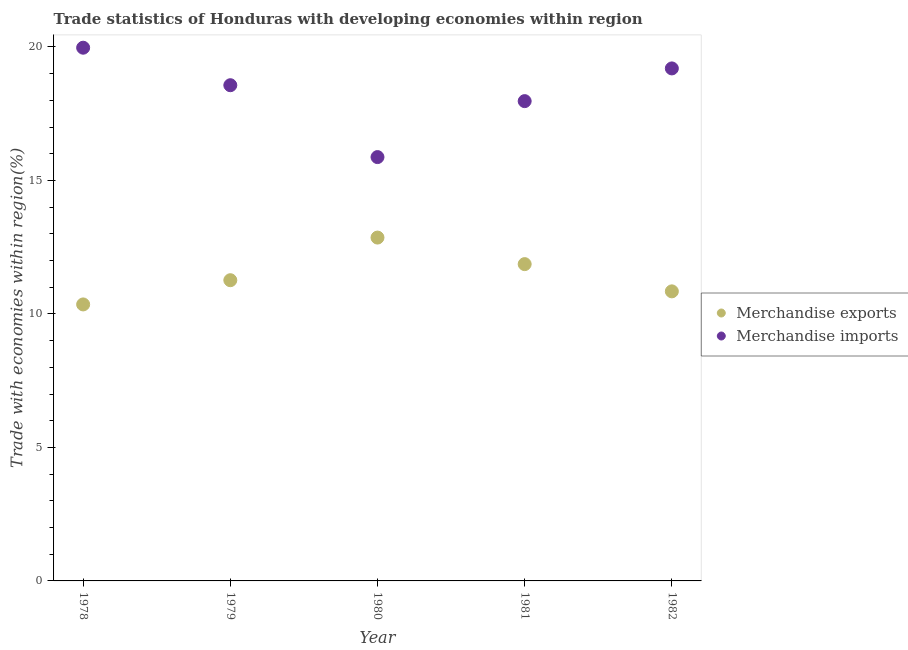How many different coloured dotlines are there?
Your answer should be very brief. 2. What is the merchandise exports in 1979?
Give a very brief answer. 11.26. Across all years, what is the maximum merchandise imports?
Ensure brevity in your answer.  19.97. Across all years, what is the minimum merchandise exports?
Offer a very short reply. 10.36. In which year was the merchandise exports maximum?
Your answer should be very brief. 1980. In which year was the merchandise imports minimum?
Give a very brief answer. 1980. What is the total merchandise exports in the graph?
Your response must be concise. 57.2. What is the difference between the merchandise imports in 1978 and that in 1981?
Your answer should be compact. 2. What is the difference between the merchandise exports in 1982 and the merchandise imports in 1978?
Your response must be concise. -9.13. What is the average merchandise imports per year?
Offer a terse response. 18.32. In the year 1982, what is the difference between the merchandise imports and merchandise exports?
Your answer should be compact. 8.35. What is the ratio of the merchandise exports in 1979 to that in 1981?
Provide a succinct answer. 0.95. Is the merchandise exports in 1978 less than that in 1979?
Provide a succinct answer. Yes. Is the difference between the merchandise exports in 1978 and 1979 greater than the difference between the merchandise imports in 1978 and 1979?
Your answer should be very brief. No. What is the difference between the highest and the second highest merchandise imports?
Ensure brevity in your answer.  0.78. What is the difference between the highest and the lowest merchandise imports?
Provide a short and direct response. 4.1. Is the merchandise imports strictly greater than the merchandise exports over the years?
Your answer should be compact. Yes. How many dotlines are there?
Give a very brief answer. 2. How many years are there in the graph?
Offer a terse response. 5. What is the difference between two consecutive major ticks on the Y-axis?
Your response must be concise. 5. Are the values on the major ticks of Y-axis written in scientific E-notation?
Offer a very short reply. No. Does the graph contain any zero values?
Your answer should be compact. No. How many legend labels are there?
Give a very brief answer. 2. How are the legend labels stacked?
Offer a terse response. Vertical. What is the title of the graph?
Give a very brief answer. Trade statistics of Honduras with developing economies within region. What is the label or title of the Y-axis?
Offer a very short reply. Trade with economies within region(%). What is the Trade with economies within region(%) of Merchandise exports in 1978?
Offer a very short reply. 10.36. What is the Trade with economies within region(%) of Merchandise imports in 1978?
Your answer should be compact. 19.97. What is the Trade with economies within region(%) in Merchandise exports in 1979?
Provide a short and direct response. 11.26. What is the Trade with economies within region(%) in Merchandise imports in 1979?
Your answer should be very brief. 18.57. What is the Trade with economies within region(%) in Merchandise exports in 1980?
Provide a short and direct response. 12.86. What is the Trade with economies within region(%) in Merchandise imports in 1980?
Ensure brevity in your answer.  15.88. What is the Trade with economies within region(%) in Merchandise exports in 1981?
Keep it short and to the point. 11.87. What is the Trade with economies within region(%) in Merchandise imports in 1981?
Your response must be concise. 17.97. What is the Trade with economies within region(%) of Merchandise exports in 1982?
Make the answer very short. 10.85. What is the Trade with economies within region(%) in Merchandise imports in 1982?
Offer a very short reply. 19.2. Across all years, what is the maximum Trade with economies within region(%) in Merchandise exports?
Your response must be concise. 12.86. Across all years, what is the maximum Trade with economies within region(%) in Merchandise imports?
Provide a succinct answer. 19.97. Across all years, what is the minimum Trade with economies within region(%) of Merchandise exports?
Give a very brief answer. 10.36. Across all years, what is the minimum Trade with economies within region(%) in Merchandise imports?
Your answer should be very brief. 15.88. What is the total Trade with economies within region(%) of Merchandise exports in the graph?
Give a very brief answer. 57.2. What is the total Trade with economies within region(%) of Merchandise imports in the graph?
Offer a terse response. 91.59. What is the difference between the Trade with economies within region(%) of Merchandise exports in 1978 and that in 1979?
Provide a succinct answer. -0.91. What is the difference between the Trade with economies within region(%) of Merchandise imports in 1978 and that in 1979?
Offer a very short reply. 1.4. What is the difference between the Trade with economies within region(%) in Merchandise exports in 1978 and that in 1980?
Provide a short and direct response. -2.5. What is the difference between the Trade with economies within region(%) of Merchandise imports in 1978 and that in 1980?
Offer a terse response. 4.1. What is the difference between the Trade with economies within region(%) in Merchandise exports in 1978 and that in 1981?
Give a very brief answer. -1.51. What is the difference between the Trade with economies within region(%) of Merchandise imports in 1978 and that in 1981?
Ensure brevity in your answer.  2. What is the difference between the Trade with economies within region(%) in Merchandise exports in 1978 and that in 1982?
Give a very brief answer. -0.49. What is the difference between the Trade with economies within region(%) in Merchandise imports in 1978 and that in 1982?
Offer a very short reply. 0.78. What is the difference between the Trade with economies within region(%) of Merchandise exports in 1979 and that in 1980?
Ensure brevity in your answer.  -1.6. What is the difference between the Trade with economies within region(%) of Merchandise imports in 1979 and that in 1980?
Ensure brevity in your answer.  2.69. What is the difference between the Trade with economies within region(%) in Merchandise exports in 1979 and that in 1981?
Provide a succinct answer. -0.6. What is the difference between the Trade with economies within region(%) in Merchandise imports in 1979 and that in 1981?
Offer a very short reply. 0.6. What is the difference between the Trade with economies within region(%) of Merchandise exports in 1979 and that in 1982?
Make the answer very short. 0.42. What is the difference between the Trade with economies within region(%) in Merchandise imports in 1979 and that in 1982?
Ensure brevity in your answer.  -0.63. What is the difference between the Trade with economies within region(%) of Merchandise imports in 1980 and that in 1981?
Your answer should be very brief. -2.1. What is the difference between the Trade with economies within region(%) in Merchandise exports in 1980 and that in 1982?
Offer a terse response. 2.01. What is the difference between the Trade with economies within region(%) in Merchandise imports in 1980 and that in 1982?
Provide a succinct answer. -3.32. What is the difference between the Trade with economies within region(%) of Merchandise exports in 1981 and that in 1982?
Give a very brief answer. 1.02. What is the difference between the Trade with economies within region(%) in Merchandise imports in 1981 and that in 1982?
Provide a succinct answer. -1.23. What is the difference between the Trade with economies within region(%) of Merchandise exports in 1978 and the Trade with economies within region(%) of Merchandise imports in 1979?
Give a very brief answer. -8.21. What is the difference between the Trade with economies within region(%) of Merchandise exports in 1978 and the Trade with economies within region(%) of Merchandise imports in 1980?
Give a very brief answer. -5.52. What is the difference between the Trade with economies within region(%) in Merchandise exports in 1978 and the Trade with economies within region(%) in Merchandise imports in 1981?
Your response must be concise. -7.62. What is the difference between the Trade with economies within region(%) in Merchandise exports in 1978 and the Trade with economies within region(%) in Merchandise imports in 1982?
Provide a succinct answer. -8.84. What is the difference between the Trade with economies within region(%) of Merchandise exports in 1979 and the Trade with economies within region(%) of Merchandise imports in 1980?
Your answer should be compact. -4.61. What is the difference between the Trade with economies within region(%) in Merchandise exports in 1979 and the Trade with economies within region(%) in Merchandise imports in 1981?
Offer a very short reply. -6.71. What is the difference between the Trade with economies within region(%) of Merchandise exports in 1979 and the Trade with economies within region(%) of Merchandise imports in 1982?
Offer a very short reply. -7.93. What is the difference between the Trade with economies within region(%) of Merchandise exports in 1980 and the Trade with economies within region(%) of Merchandise imports in 1981?
Make the answer very short. -5.11. What is the difference between the Trade with economies within region(%) in Merchandise exports in 1980 and the Trade with economies within region(%) in Merchandise imports in 1982?
Provide a succinct answer. -6.34. What is the difference between the Trade with economies within region(%) in Merchandise exports in 1981 and the Trade with economies within region(%) in Merchandise imports in 1982?
Provide a short and direct response. -7.33. What is the average Trade with economies within region(%) in Merchandise exports per year?
Provide a short and direct response. 11.44. What is the average Trade with economies within region(%) in Merchandise imports per year?
Make the answer very short. 18.32. In the year 1978, what is the difference between the Trade with economies within region(%) of Merchandise exports and Trade with economies within region(%) of Merchandise imports?
Give a very brief answer. -9.62. In the year 1979, what is the difference between the Trade with economies within region(%) of Merchandise exports and Trade with economies within region(%) of Merchandise imports?
Keep it short and to the point. -7.3. In the year 1980, what is the difference between the Trade with economies within region(%) of Merchandise exports and Trade with economies within region(%) of Merchandise imports?
Your response must be concise. -3.01. In the year 1981, what is the difference between the Trade with economies within region(%) in Merchandise exports and Trade with economies within region(%) in Merchandise imports?
Offer a terse response. -6.11. In the year 1982, what is the difference between the Trade with economies within region(%) of Merchandise exports and Trade with economies within region(%) of Merchandise imports?
Ensure brevity in your answer.  -8.35. What is the ratio of the Trade with economies within region(%) of Merchandise exports in 1978 to that in 1979?
Provide a succinct answer. 0.92. What is the ratio of the Trade with economies within region(%) in Merchandise imports in 1978 to that in 1979?
Give a very brief answer. 1.08. What is the ratio of the Trade with economies within region(%) in Merchandise exports in 1978 to that in 1980?
Give a very brief answer. 0.81. What is the ratio of the Trade with economies within region(%) in Merchandise imports in 1978 to that in 1980?
Offer a terse response. 1.26. What is the ratio of the Trade with economies within region(%) of Merchandise exports in 1978 to that in 1981?
Your answer should be very brief. 0.87. What is the ratio of the Trade with economies within region(%) in Merchandise imports in 1978 to that in 1981?
Offer a very short reply. 1.11. What is the ratio of the Trade with economies within region(%) in Merchandise exports in 1978 to that in 1982?
Your answer should be compact. 0.95. What is the ratio of the Trade with economies within region(%) of Merchandise imports in 1978 to that in 1982?
Your answer should be very brief. 1.04. What is the ratio of the Trade with economies within region(%) of Merchandise exports in 1979 to that in 1980?
Your answer should be very brief. 0.88. What is the ratio of the Trade with economies within region(%) of Merchandise imports in 1979 to that in 1980?
Ensure brevity in your answer.  1.17. What is the ratio of the Trade with economies within region(%) of Merchandise exports in 1979 to that in 1981?
Ensure brevity in your answer.  0.95. What is the ratio of the Trade with economies within region(%) of Merchandise imports in 1979 to that in 1981?
Provide a short and direct response. 1.03. What is the ratio of the Trade with economies within region(%) in Merchandise imports in 1979 to that in 1982?
Your answer should be very brief. 0.97. What is the ratio of the Trade with economies within region(%) of Merchandise exports in 1980 to that in 1981?
Keep it short and to the point. 1.08. What is the ratio of the Trade with economies within region(%) of Merchandise imports in 1980 to that in 1981?
Offer a terse response. 0.88. What is the ratio of the Trade with economies within region(%) of Merchandise exports in 1980 to that in 1982?
Make the answer very short. 1.19. What is the ratio of the Trade with economies within region(%) of Merchandise imports in 1980 to that in 1982?
Your answer should be compact. 0.83. What is the ratio of the Trade with economies within region(%) of Merchandise exports in 1981 to that in 1982?
Offer a very short reply. 1.09. What is the ratio of the Trade with economies within region(%) in Merchandise imports in 1981 to that in 1982?
Your answer should be compact. 0.94. What is the difference between the highest and the second highest Trade with economies within region(%) of Merchandise imports?
Keep it short and to the point. 0.78. What is the difference between the highest and the lowest Trade with economies within region(%) of Merchandise exports?
Offer a very short reply. 2.5. What is the difference between the highest and the lowest Trade with economies within region(%) of Merchandise imports?
Provide a short and direct response. 4.1. 